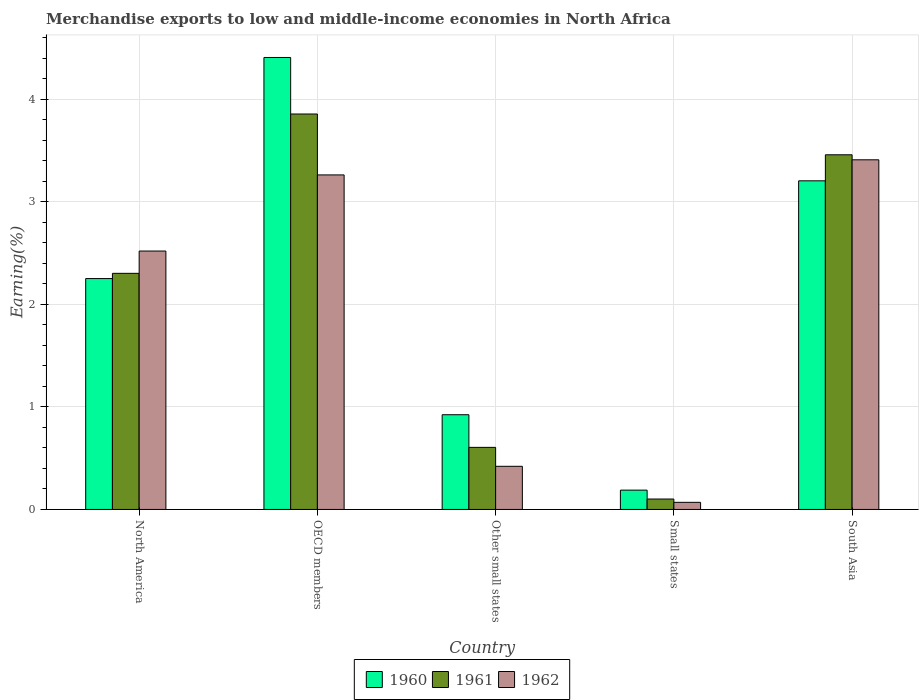How many groups of bars are there?
Make the answer very short. 5. How many bars are there on the 3rd tick from the left?
Keep it short and to the point. 3. What is the label of the 4th group of bars from the left?
Provide a short and direct response. Small states. What is the percentage of amount earned from merchandise exports in 1962 in Other small states?
Provide a short and direct response. 0.42. Across all countries, what is the maximum percentage of amount earned from merchandise exports in 1960?
Ensure brevity in your answer.  4.41. Across all countries, what is the minimum percentage of amount earned from merchandise exports in 1960?
Offer a terse response. 0.19. In which country was the percentage of amount earned from merchandise exports in 1961 minimum?
Your answer should be very brief. Small states. What is the total percentage of amount earned from merchandise exports in 1960 in the graph?
Your answer should be compact. 10.98. What is the difference between the percentage of amount earned from merchandise exports in 1960 in North America and that in Other small states?
Your response must be concise. 1.33. What is the difference between the percentage of amount earned from merchandise exports in 1961 in Small states and the percentage of amount earned from merchandise exports in 1960 in North America?
Your answer should be compact. -2.15. What is the average percentage of amount earned from merchandise exports in 1961 per country?
Your answer should be compact. 2.07. What is the difference between the percentage of amount earned from merchandise exports of/in 1960 and percentage of amount earned from merchandise exports of/in 1961 in North America?
Keep it short and to the point. -0.05. What is the ratio of the percentage of amount earned from merchandise exports in 1962 in OECD members to that in Other small states?
Offer a terse response. 7.75. Is the difference between the percentage of amount earned from merchandise exports in 1960 in OECD members and Other small states greater than the difference between the percentage of amount earned from merchandise exports in 1961 in OECD members and Other small states?
Keep it short and to the point. Yes. What is the difference between the highest and the second highest percentage of amount earned from merchandise exports in 1960?
Your response must be concise. -0.95. What is the difference between the highest and the lowest percentage of amount earned from merchandise exports in 1960?
Make the answer very short. 4.22. In how many countries, is the percentage of amount earned from merchandise exports in 1960 greater than the average percentage of amount earned from merchandise exports in 1960 taken over all countries?
Your answer should be very brief. 3. Is the sum of the percentage of amount earned from merchandise exports in 1961 in OECD members and Small states greater than the maximum percentage of amount earned from merchandise exports in 1960 across all countries?
Keep it short and to the point. No. How many countries are there in the graph?
Keep it short and to the point. 5. What is the difference between two consecutive major ticks on the Y-axis?
Keep it short and to the point. 1. Are the values on the major ticks of Y-axis written in scientific E-notation?
Offer a very short reply. No. Does the graph contain any zero values?
Your answer should be very brief. No. How many legend labels are there?
Provide a succinct answer. 3. What is the title of the graph?
Your response must be concise. Merchandise exports to low and middle-income economies in North Africa. What is the label or title of the Y-axis?
Keep it short and to the point. Earning(%). What is the Earning(%) in 1960 in North America?
Give a very brief answer. 2.25. What is the Earning(%) in 1961 in North America?
Keep it short and to the point. 2.3. What is the Earning(%) in 1962 in North America?
Make the answer very short. 2.52. What is the Earning(%) in 1960 in OECD members?
Give a very brief answer. 4.41. What is the Earning(%) of 1961 in OECD members?
Make the answer very short. 3.86. What is the Earning(%) in 1962 in OECD members?
Make the answer very short. 3.26. What is the Earning(%) in 1960 in Other small states?
Your answer should be very brief. 0.92. What is the Earning(%) of 1961 in Other small states?
Keep it short and to the point. 0.61. What is the Earning(%) of 1962 in Other small states?
Your response must be concise. 0.42. What is the Earning(%) in 1960 in Small states?
Provide a succinct answer. 0.19. What is the Earning(%) of 1961 in Small states?
Your response must be concise. 0.1. What is the Earning(%) of 1962 in Small states?
Make the answer very short. 0.07. What is the Earning(%) of 1960 in South Asia?
Provide a succinct answer. 3.21. What is the Earning(%) of 1961 in South Asia?
Provide a succinct answer. 3.46. What is the Earning(%) in 1962 in South Asia?
Your response must be concise. 3.41. Across all countries, what is the maximum Earning(%) in 1960?
Your answer should be very brief. 4.41. Across all countries, what is the maximum Earning(%) in 1961?
Your answer should be compact. 3.86. Across all countries, what is the maximum Earning(%) of 1962?
Give a very brief answer. 3.41. Across all countries, what is the minimum Earning(%) of 1960?
Provide a short and direct response. 0.19. Across all countries, what is the minimum Earning(%) in 1961?
Your answer should be very brief. 0.1. Across all countries, what is the minimum Earning(%) of 1962?
Keep it short and to the point. 0.07. What is the total Earning(%) in 1960 in the graph?
Keep it short and to the point. 10.98. What is the total Earning(%) of 1961 in the graph?
Make the answer very short. 10.33. What is the total Earning(%) in 1962 in the graph?
Provide a succinct answer. 9.68. What is the difference between the Earning(%) of 1960 in North America and that in OECD members?
Your answer should be compact. -2.16. What is the difference between the Earning(%) in 1961 in North America and that in OECD members?
Your answer should be very brief. -1.55. What is the difference between the Earning(%) of 1962 in North America and that in OECD members?
Your response must be concise. -0.74. What is the difference between the Earning(%) of 1960 in North America and that in Other small states?
Make the answer very short. 1.33. What is the difference between the Earning(%) in 1961 in North America and that in Other small states?
Keep it short and to the point. 1.7. What is the difference between the Earning(%) in 1962 in North America and that in Other small states?
Your answer should be compact. 2.1. What is the difference between the Earning(%) of 1960 in North America and that in Small states?
Provide a short and direct response. 2.06. What is the difference between the Earning(%) in 1961 in North America and that in Small states?
Give a very brief answer. 2.2. What is the difference between the Earning(%) in 1962 in North America and that in Small states?
Offer a terse response. 2.45. What is the difference between the Earning(%) of 1960 in North America and that in South Asia?
Keep it short and to the point. -0.95. What is the difference between the Earning(%) of 1961 in North America and that in South Asia?
Your answer should be very brief. -1.16. What is the difference between the Earning(%) in 1962 in North America and that in South Asia?
Keep it short and to the point. -0.89. What is the difference between the Earning(%) of 1960 in OECD members and that in Other small states?
Offer a terse response. 3.48. What is the difference between the Earning(%) in 1961 in OECD members and that in Other small states?
Make the answer very short. 3.25. What is the difference between the Earning(%) in 1962 in OECD members and that in Other small states?
Offer a terse response. 2.84. What is the difference between the Earning(%) in 1960 in OECD members and that in Small states?
Provide a succinct answer. 4.22. What is the difference between the Earning(%) of 1961 in OECD members and that in Small states?
Your answer should be very brief. 3.76. What is the difference between the Earning(%) in 1962 in OECD members and that in Small states?
Your answer should be very brief. 3.19. What is the difference between the Earning(%) of 1960 in OECD members and that in South Asia?
Keep it short and to the point. 1.2. What is the difference between the Earning(%) of 1961 in OECD members and that in South Asia?
Your answer should be compact. 0.4. What is the difference between the Earning(%) of 1962 in OECD members and that in South Asia?
Keep it short and to the point. -0.15. What is the difference between the Earning(%) in 1960 in Other small states and that in Small states?
Your answer should be very brief. 0.74. What is the difference between the Earning(%) of 1961 in Other small states and that in Small states?
Your response must be concise. 0.5. What is the difference between the Earning(%) in 1962 in Other small states and that in Small states?
Provide a succinct answer. 0.35. What is the difference between the Earning(%) in 1960 in Other small states and that in South Asia?
Ensure brevity in your answer.  -2.28. What is the difference between the Earning(%) in 1961 in Other small states and that in South Asia?
Your answer should be compact. -2.85. What is the difference between the Earning(%) of 1962 in Other small states and that in South Asia?
Provide a short and direct response. -2.99. What is the difference between the Earning(%) in 1960 in Small states and that in South Asia?
Provide a short and direct response. -3.02. What is the difference between the Earning(%) in 1961 in Small states and that in South Asia?
Give a very brief answer. -3.36. What is the difference between the Earning(%) of 1962 in Small states and that in South Asia?
Your answer should be very brief. -3.34. What is the difference between the Earning(%) in 1960 in North America and the Earning(%) in 1961 in OECD members?
Offer a very short reply. -1.6. What is the difference between the Earning(%) in 1960 in North America and the Earning(%) in 1962 in OECD members?
Provide a short and direct response. -1.01. What is the difference between the Earning(%) in 1961 in North America and the Earning(%) in 1962 in OECD members?
Your answer should be very brief. -0.96. What is the difference between the Earning(%) of 1960 in North America and the Earning(%) of 1961 in Other small states?
Offer a very short reply. 1.65. What is the difference between the Earning(%) in 1960 in North America and the Earning(%) in 1962 in Other small states?
Make the answer very short. 1.83. What is the difference between the Earning(%) in 1961 in North America and the Earning(%) in 1962 in Other small states?
Your answer should be very brief. 1.88. What is the difference between the Earning(%) in 1960 in North America and the Earning(%) in 1961 in Small states?
Ensure brevity in your answer.  2.15. What is the difference between the Earning(%) of 1960 in North America and the Earning(%) of 1962 in Small states?
Provide a succinct answer. 2.18. What is the difference between the Earning(%) in 1961 in North America and the Earning(%) in 1962 in Small states?
Make the answer very short. 2.23. What is the difference between the Earning(%) in 1960 in North America and the Earning(%) in 1961 in South Asia?
Provide a succinct answer. -1.21. What is the difference between the Earning(%) in 1960 in North America and the Earning(%) in 1962 in South Asia?
Offer a very short reply. -1.16. What is the difference between the Earning(%) in 1961 in North America and the Earning(%) in 1962 in South Asia?
Give a very brief answer. -1.11. What is the difference between the Earning(%) of 1960 in OECD members and the Earning(%) of 1961 in Other small states?
Give a very brief answer. 3.8. What is the difference between the Earning(%) of 1960 in OECD members and the Earning(%) of 1962 in Other small states?
Ensure brevity in your answer.  3.99. What is the difference between the Earning(%) in 1961 in OECD members and the Earning(%) in 1962 in Other small states?
Offer a very short reply. 3.44. What is the difference between the Earning(%) in 1960 in OECD members and the Earning(%) in 1961 in Small states?
Provide a short and direct response. 4.31. What is the difference between the Earning(%) in 1960 in OECD members and the Earning(%) in 1962 in Small states?
Your answer should be very brief. 4.34. What is the difference between the Earning(%) in 1961 in OECD members and the Earning(%) in 1962 in Small states?
Your answer should be compact. 3.79. What is the difference between the Earning(%) in 1960 in OECD members and the Earning(%) in 1961 in South Asia?
Offer a very short reply. 0.95. What is the difference between the Earning(%) of 1961 in OECD members and the Earning(%) of 1962 in South Asia?
Offer a terse response. 0.45. What is the difference between the Earning(%) in 1960 in Other small states and the Earning(%) in 1961 in Small states?
Your answer should be compact. 0.82. What is the difference between the Earning(%) of 1960 in Other small states and the Earning(%) of 1962 in Small states?
Keep it short and to the point. 0.85. What is the difference between the Earning(%) of 1961 in Other small states and the Earning(%) of 1962 in Small states?
Your answer should be compact. 0.54. What is the difference between the Earning(%) of 1960 in Other small states and the Earning(%) of 1961 in South Asia?
Give a very brief answer. -2.54. What is the difference between the Earning(%) of 1960 in Other small states and the Earning(%) of 1962 in South Asia?
Ensure brevity in your answer.  -2.49. What is the difference between the Earning(%) in 1961 in Other small states and the Earning(%) in 1962 in South Asia?
Give a very brief answer. -2.8. What is the difference between the Earning(%) in 1960 in Small states and the Earning(%) in 1961 in South Asia?
Provide a succinct answer. -3.27. What is the difference between the Earning(%) of 1960 in Small states and the Earning(%) of 1962 in South Asia?
Provide a succinct answer. -3.22. What is the difference between the Earning(%) in 1961 in Small states and the Earning(%) in 1962 in South Asia?
Your response must be concise. -3.31. What is the average Earning(%) of 1960 per country?
Offer a terse response. 2.2. What is the average Earning(%) of 1961 per country?
Offer a terse response. 2.07. What is the average Earning(%) of 1962 per country?
Make the answer very short. 1.94. What is the difference between the Earning(%) in 1960 and Earning(%) in 1961 in North America?
Keep it short and to the point. -0.05. What is the difference between the Earning(%) of 1960 and Earning(%) of 1962 in North America?
Make the answer very short. -0.27. What is the difference between the Earning(%) of 1961 and Earning(%) of 1962 in North America?
Make the answer very short. -0.22. What is the difference between the Earning(%) of 1960 and Earning(%) of 1961 in OECD members?
Make the answer very short. 0.55. What is the difference between the Earning(%) of 1960 and Earning(%) of 1962 in OECD members?
Your answer should be very brief. 1.15. What is the difference between the Earning(%) in 1961 and Earning(%) in 1962 in OECD members?
Keep it short and to the point. 0.59. What is the difference between the Earning(%) of 1960 and Earning(%) of 1961 in Other small states?
Ensure brevity in your answer.  0.32. What is the difference between the Earning(%) in 1960 and Earning(%) in 1962 in Other small states?
Provide a short and direct response. 0.5. What is the difference between the Earning(%) in 1961 and Earning(%) in 1962 in Other small states?
Provide a succinct answer. 0.18. What is the difference between the Earning(%) of 1960 and Earning(%) of 1961 in Small states?
Ensure brevity in your answer.  0.09. What is the difference between the Earning(%) of 1960 and Earning(%) of 1962 in Small states?
Give a very brief answer. 0.12. What is the difference between the Earning(%) in 1961 and Earning(%) in 1962 in Small states?
Offer a very short reply. 0.03. What is the difference between the Earning(%) of 1960 and Earning(%) of 1961 in South Asia?
Offer a terse response. -0.25. What is the difference between the Earning(%) in 1960 and Earning(%) in 1962 in South Asia?
Make the answer very short. -0.2. What is the difference between the Earning(%) of 1961 and Earning(%) of 1962 in South Asia?
Your answer should be very brief. 0.05. What is the ratio of the Earning(%) of 1960 in North America to that in OECD members?
Provide a succinct answer. 0.51. What is the ratio of the Earning(%) of 1961 in North America to that in OECD members?
Offer a very short reply. 0.6. What is the ratio of the Earning(%) in 1962 in North America to that in OECD members?
Your response must be concise. 0.77. What is the ratio of the Earning(%) of 1960 in North America to that in Other small states?
Your answer should be very brief. 2.44. What is the ratio of the Earning(%) in 1961 in North America to that in Other small states?
Your answer should be very brief. 3.8. What is the ratio of the Earning(%) of 1962 in North America to that in Other small states?
Your answer should be compact. 5.99. What is the ratio of the Earning(%) in 1960 in North America to that in Small states?
Give a very brief answer. 11.95. What is the ratio of the Earning(%) of 1961 in North America to that in Small states?
Make the answer very short. 22.66. What is the ratio of the Earning(%) of 1962 in North America to that in Small states?
Your answer should be very brief. 36.29. What is the ratio of the Earning(%) of 1960 in North America to that in South Asia?
Your response must be concise. 0.7. What is the ratio of the Earning(%) in 1961 in North America to that in South Asia?
Your answer should be very brief. 0.67. What is the ratio of the Earning(%) in 1962 in North America to that in South Asia?
Give a very brief answer. 0.74. What is the ratio of the Earning(%) of 1960 in OECD members to that in Other small states?
Your response must be concise. 4.77. What is the ratio of the Earning(%) of 1961 in OECD members to that in Other small states?
Your response must be concise. 6.37. What is the ratio of the Earning(%) in 1962 in OECD members to that in Other small states?
Offer a terse response. 7.75. What is the ratio of the Earning(%) of 1960 in OECD members to that in Small states?
Your answer should be compact. 23.4. What is the ratio of the Earning(%) of 1961 in OECD members to that in Small states?
Your answer should be compact. 37.95. What is the ratio of the Earning(%) in 1962 in OECD members to that in Small states?
Make the answer very short. 46.98. What is the ratio of the Earning(%) in 1960 in OECD members to that in South Asia?
Offer a very short reply. 1.38. What is the ratio of the Earning(%) in 1961 in OECD members to that in South Asia?
Provide a succinct answer. 1.11. What is the ratio of the Earning(%) of 1962 in OECD members to that in South Asia?
Provide a short and direct response. 0.96. What is the ratio of the Earning(%) in 1960 in Other small states to that in Small states?
Provide a short and direct response. 4.9. What is the ratio of the Earning(%) of 1961 in Other small states to that in Small states?
Ensure brevity in your answer.  5.96. What is the ratio of the Earning(%) of 1962 in Other small states to that in Small states?
Make the answer very short. 6.06. What is the ratio of the Earning(%) in 1960 in Other small states to that in South Asia?
Your response must be concise. 0.29. What is the ratio of the Earning(%) in 1961 in Other small states to that in South Asia?
Make the answer very short. 0.18. What is the ratio of the Earning(%) in 1962 in Other small states to that in South Asia?
Offer a terse response. 0.12. What is the ratio of the Earning(%) in 1960 in Small states to that in South Asia?
Provide a succinct answer. 0.06. What is the ratio of the Earning(%) in 1961 in Small states to that in South Asia?
Your answer should be compact. 0.03. What is the ratio of the Earning(%) of 1962 in Small states to that in South Asia?
Make the answer very short. 0.02. What is the difference between the highest and the second highest Earning(%) in 1960?
Give a very brief answer. 1.2. What is the difference between the highest and the second highest Earning(%) of 1961?
Provide a short and direct response. 0.4. What is the difference between the highest and the second highest Earning(%) in 1962?
Make the answer very short. 0.15. What is the difference between the highest and the lowest Earning(%) in 1960?
Provide a short and direct response. 4.22. What is the difference between the highest and the lowest Earning(%) in 1961?
Make the answer very short. 3.76. What is the difference between the highest and the lowest Earning(%) in 1962?
Provide a short and direct response. 3.34. 